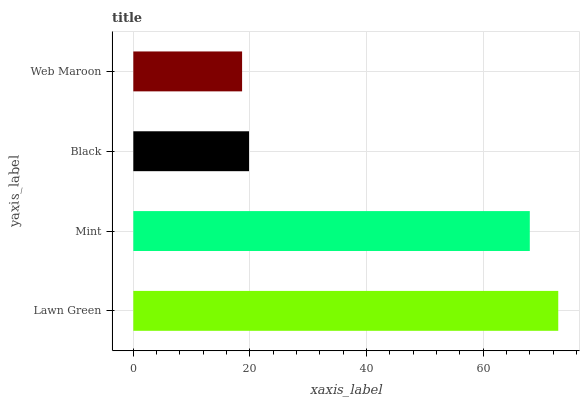Is Web Maroon the minimum?
Answer yes or no. Yes. Is Lawn Green the maximum?
Answer yes or no. Yes. Is Mint the minimum?
Answer yes or no. No. Is Mint the maximum?
Answer yes or no. No. Is Lawn Green greater than Mint?
Answer yes or no. Yes. Is Mint less than Lawn Green?
Answer yes or no. Yes. Is Mint greater than Lawn Green?
Answer yes or no. No. Is Lawn Green less than Mint?
Answer yes or no. No. Is Mint the high median?
Answer yes or no. Yes. Is Black the low median?
Answer yes or no. Yes. Is Lawn Green the high median?
Answer yes or no. No. Is Lawn Green the low median?
Answer yes or no. No. 